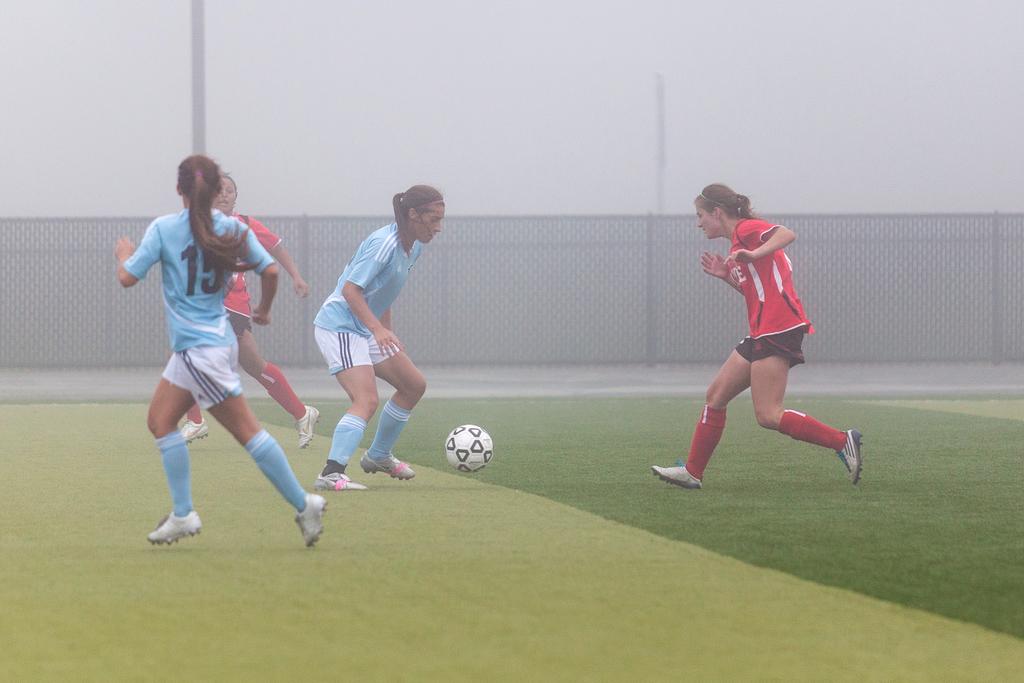What number is the girl's jersey in blue?
Provide a succinct answer. 15. How many digits is the player number of the girl in blue on the left?
Give a very brief answer. 2. 